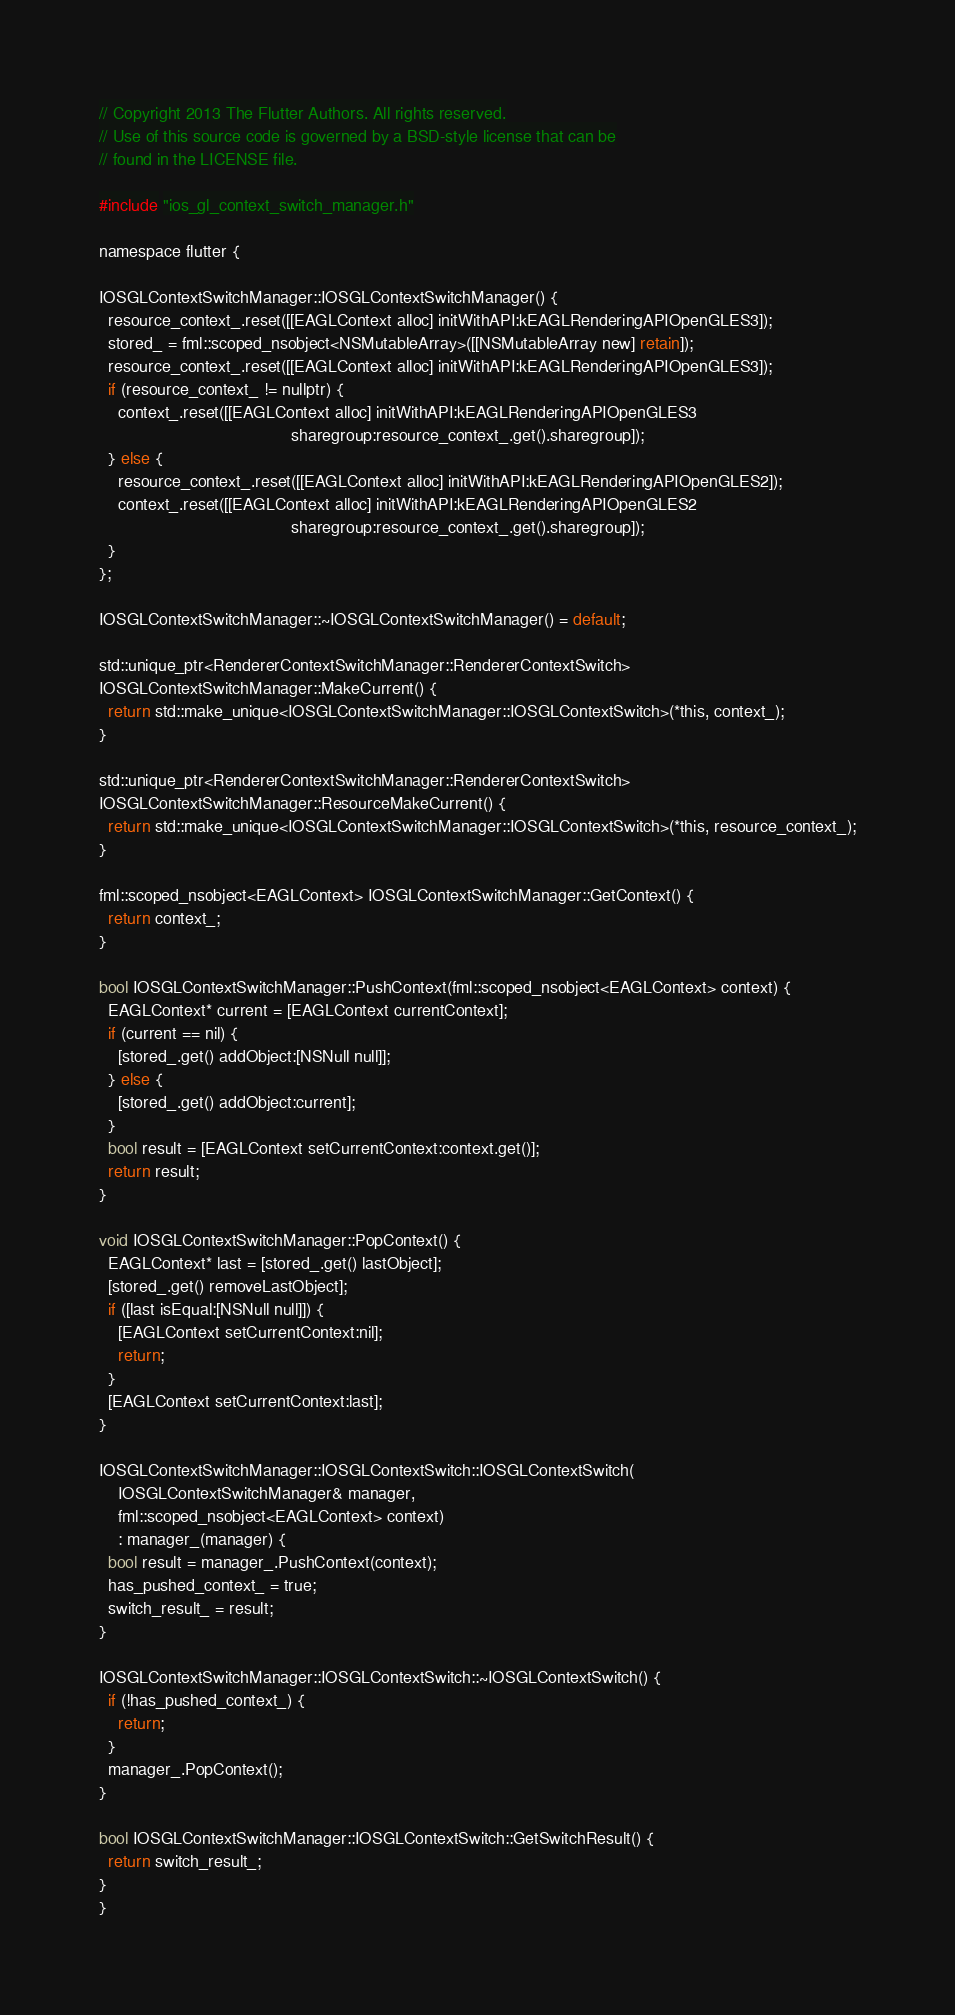Convert code to text. <code><loc_0><loc_0><loc_500><loc_500><_ObjectiveC_>// Copyright 2013 The Flutter Authors. All rights reserved.
// Use of this source code is governed by a BSD-style license that can be
// found in the LICENSE file.

#include "ios_gl_context_switch_manager.h"

namespace flutter {

IOSGLContextSwitchManager::IOSGLContextSwitchManager() {
  resource_context_.reset([[EAGLContext alloc] initWithAPI:kEAGLRenderingAPIOpenGLES3]);
  stored_ = fml::scoped_nsobject<NSMutableArray>([[NSMutableArray new] retain]);
  resource_context_.reset([[EAGLContext alloc] initWithAPI:kEAGLRenderingAPIOpenGLES3]);
  if (resource_context_ != nullptr) {
    context_.reset([[EAGLContext alloc] initWithAPI:kEAGLRenderingAPIOpenGLES3
                                         sharegroup:resource_context_.get().sharegroup]);
  } else {
    resource_context_.reset([[EAGLContext alloc] initWithAPI:kEAGLRenderingAPIOpenGLES2]);
    context_.reset([[EAGLContext alloc] initWithAPI:kEAGLRenderingAPIOpenGLES2
                                         sharegroup:resource_context_.get().sharegroup]);
  }
};

IOSGLContextSwitchManager::~IOSGLContextSwitchManager() = default;

std::unique_ptr<RendererContextSwitchManager::RendererContextSwitch>
IOSGLContextSwitchManager::MakeCurrent() {
  return std::make_unique<IOSGLContextSwitchManager::IOSGLContextSwitch>(*this, context_);
}

std::unique_ptr<RendererContextSwitchManager::RendererContextSwitch>
IOSGLContextSwitchManager::ResourceMakeCurrent() {
  return std::make_unique<IOSGLContextSwitchManager::IOSGLContextSwitch>(*this, resource_context_);
}

fml::scoped_nsobject<EAGLContext> IOSGLContextSwitchManager::GetContext() {
  return context_;
}

bool IOSGLContextSwitchManager::PushContext(fml::scoped_nsobject<EAGLContext> context) {
  EAGLContext* current = [EAGLContext currentContext];
  if (current == nil) {
    [stored_.get() addObject:[NSNull null]];
  } else {
    [stored_.get() addObject:current];
  }
  bool result = [EAGLContext setCurrentContext:context.get()];
  return result;
}

void IOSGLContextSwitchManager::PopContext() {
  EAGLContext* last = [stored_.get() lastObject];
  [stored_.get() removeLastObject];
  if ([last isEqual:[NSNull null]]) {
    [EAGLContext setCurrentContext:nil];
    return;
  }
  [EAGLContext setCurrentContext:last];
}

IOSGLContextSwitchManager::IOSGLContextSwitch::IOSGLContextSwitch(
    IOSGLContextSwitchManager& manager,
    fml::scoped_nsobject<EAGLContext> context)
    : manager_(manager) {
  bool result = manager_.PushContext(context);
  has_pushed_context_ = true;
  switch_result_ = result;
}

IOSGLContextSwitchManager::IOSGLContextSwitch::~IOSGLContextSwitch() {
  if (!has_pushed_context_) {
    return;
  }
  manager_.PopContext();
}

bool IOSGLContextSwitchManager::IOSGLContextSwitch::GetSwitchResult() {
  return switch_result_;
}
}
</code> 